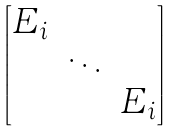Convert formula to latex. <formula><loc_0><loc_0><loc_500><loc_500>\begin{bmatrix} E _ { i } & & \\ & \ddots & \\ & & E _ { i } \end{bmatrix}</formula> 